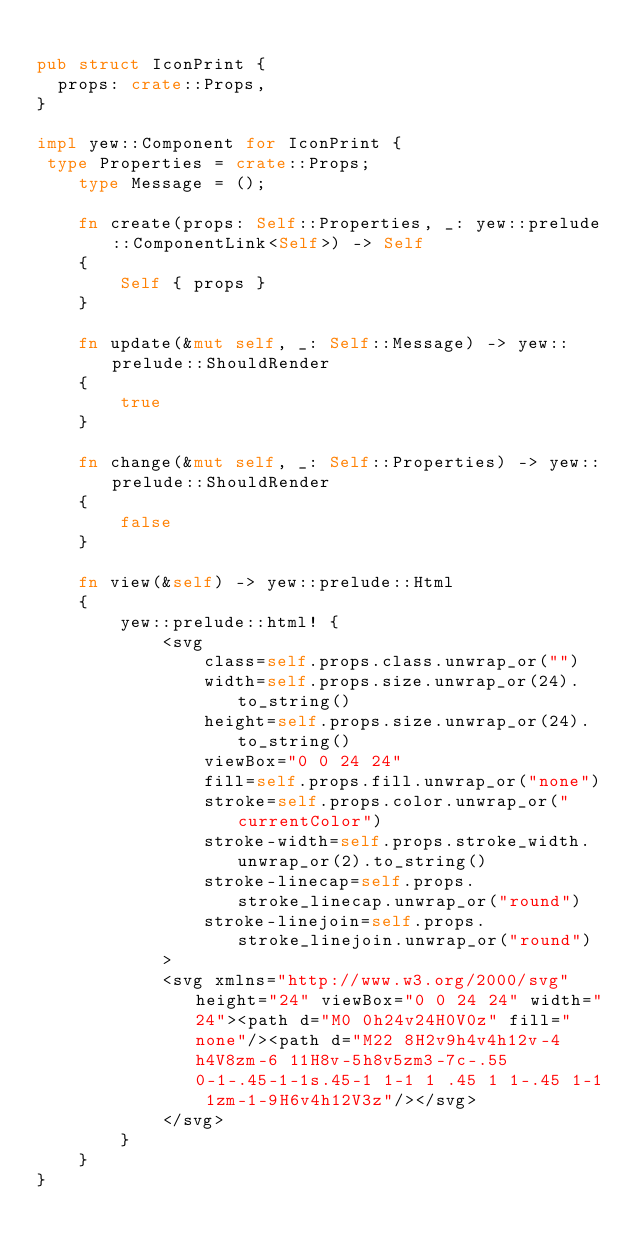<code> <loc_0><loc_0><loc_500><loc_500><_Rust_>
pub struct IconPrint {
  props: crate::Props,
}

impl yew::Component for IconPrint {
 type Properties = crate::Props;
    type Message = ();

    fn create(props: Self::Properties, _: yew::prelude::ComponentLink<Self>) -> Self
    {
        Self { props }
    }

    fn update(&mut self, _: Self::Message) -> yew::prelude::ShouldRender
    {
        true
    }

    fn change(&mut self, _: Self::Properties) -> yew::prelude::ShouldRender
    {
        false
    }

    fn view(&self) -> yew::prelude::Html
    {
        yew::prelude::html! {
            <svg
                class=self.props.class.unwrap_or("")
                width=self.props.size.unwrap_or(24).to_string()
                height=self.props.size.unwrap_or(24).to_string()
                viewBox="0 0 24 24"
                fill=self.props.fill.unwrap_or("none")
                stroke=self.props.color.unwrap_or("currentColor")
                stroke-width=self.props.stroke_width.unwrap_or(2).to_string()
                stroke-linecap=self.props.stroke_linecap.unwrap_or("round")
                stroke-linejoin=self.props.stroke_linejoin.unwrap_or("round")
            >
            <svg xmlns="http://www.w3.org/2000/svg" height="24" viewBox="0 0 24 24" width="24"><path d="M0 0h24v24H0V0z" fill="none"/><path d="M22 8H2v9h4v4h12v-4h4V8zm-6 11H8v-5h8v5zm3-7c-.55 0-1-.45-1-1s.45-1 1-1 1 .45 1 1-.45 1-1 1zm-1-9H6v4h12V3z"/></svg>
            </svg>
        }
    }
}


</code> 